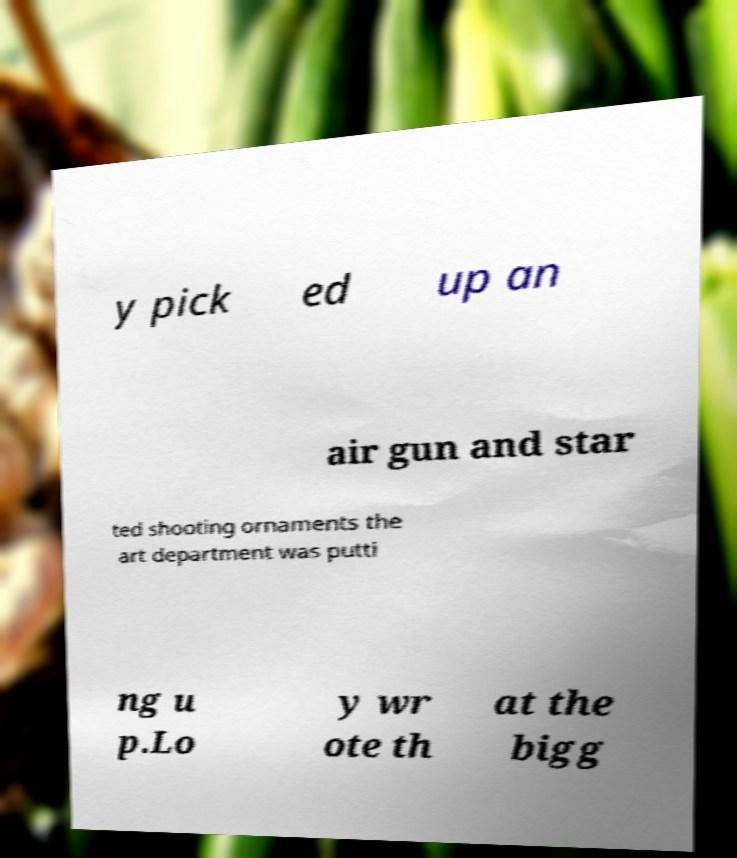What messages or text are displayed in this image? I need them in a readable, typed format. y pick ed up an air gun and star ted shooting ornaments the art department was putti ng u p.Lo y wr ote th at the bigg 